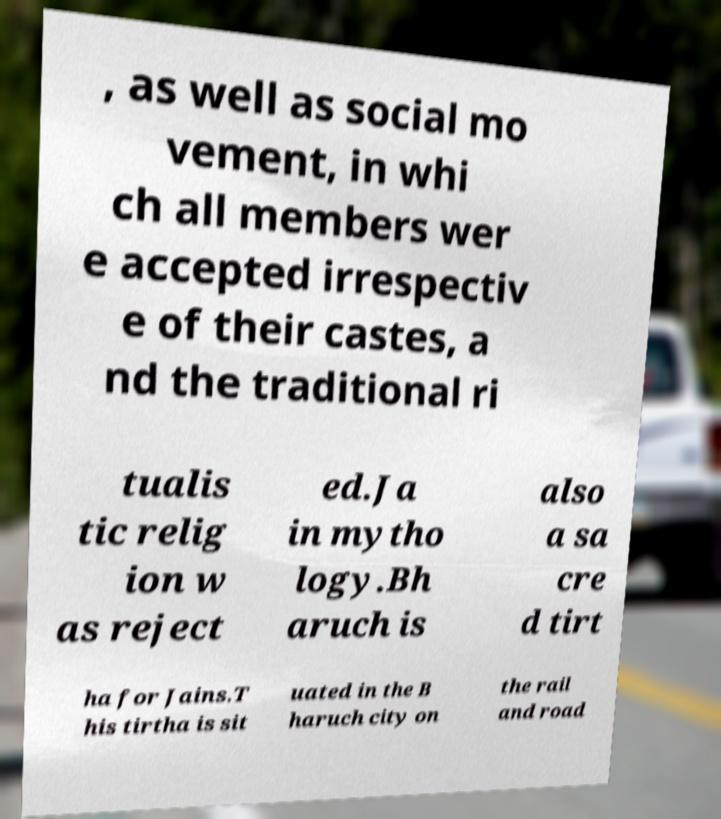Can you accurately transcribe the text from the provided image for me? , as well as social mo vement, in whi ch all members wer e accepted irrespectiv e of their castes, a nd the traditional ri tualis tic relig ion w as reject ed.Ja in mytho logy.Bh aruch is also a sa cre d tirt ha for Jains.T his tirtha is sit uated in the B haruch city on the rail and road 